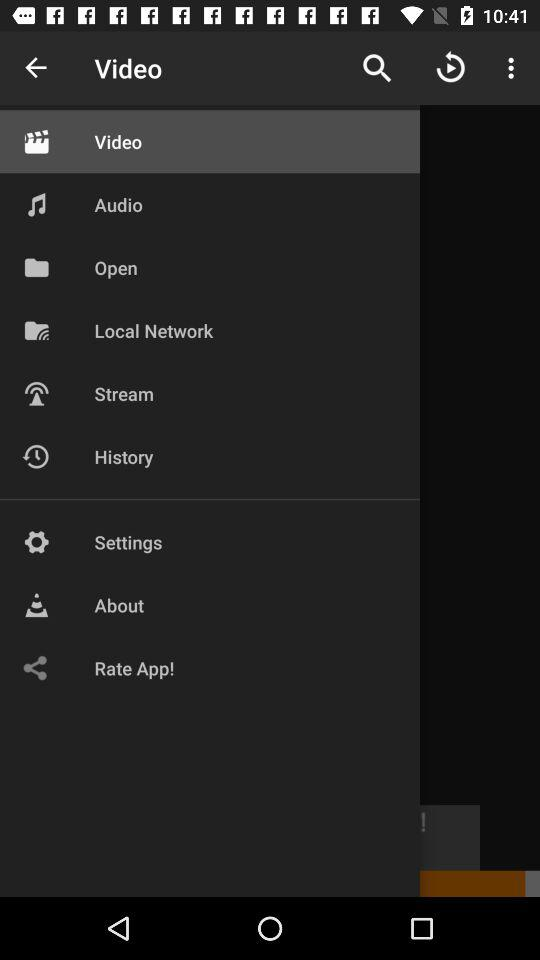How many notifications are there in "Settings"?
When the provided information is insufficient, respond with <no answer>. <no answer> 